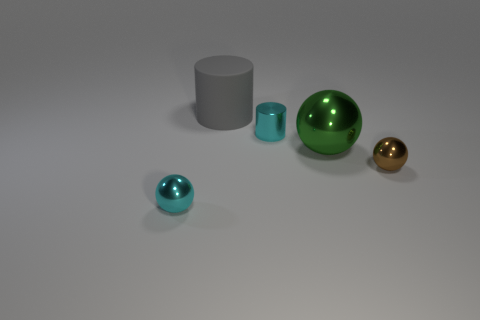What is the material of the small sphere that is the same color as the tiny metal cylinder?
Your answer should be very brief. Metal. Are the tiny cyan ball that is in front of the tiny brown shiny thing and the gray object made of the same material?
Keep it short and to the point. No. What number of things are either large green metal spheres right of the tiny metallic cylinder or red shiny cylinders?
Keep it short and to the point. 1. What is the color of the small cylinder that is made of the same material as the green ball?
Provide a short and direct response. Cyan. Are there any purple metal things of the same size as the cyan ball?
Your answer should be very brief. No. Do the metallic object that is left of the big gray cylinder and the large matte thing have the same color?
Keep it short and to the point. No. The thing that is both on the left side of the small cyan cylinder and in front of the tiny cylinder is what color?
Give a very brief answer. Cyan. There is a gray object that is the same size as the green sphere; what is its shape?
Ensure brevity in your answer.  Cylinder. Are there any brown objects of the same shape as the large green thing?
Make the answer very short. Yes. There is a metallic object that is on the left side of the cyan metal cylinder; is it the same size as the cyan cylinder?
Your answer should be compact. Yes. 